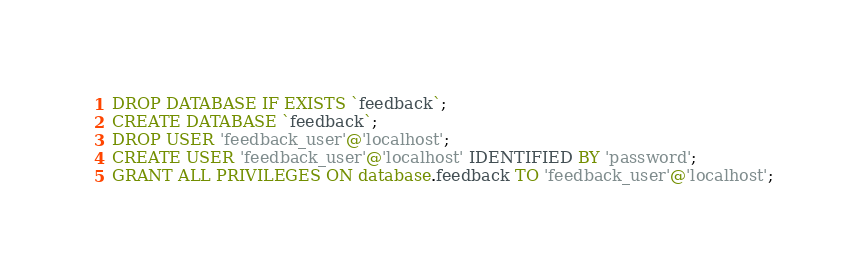<code> <loc_0><loc_0><loc_500><loc_500><_SQL_>DROP DATABASE IF EXISTS `feedback`;
CREATE DATABASE `feedback`;
DROP USER 'feedback_user'@'localhost';
CREATE USER 'feedback_user'@'localhost' IDENTIFIED BY 'password';
GRANT ALL PRIVILEGES ON database.feedback TO 'feedback_user'@'localhost';</code> 